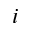<formula> <loc_0><loc_0><loc_500><loc_500>i</formula> 